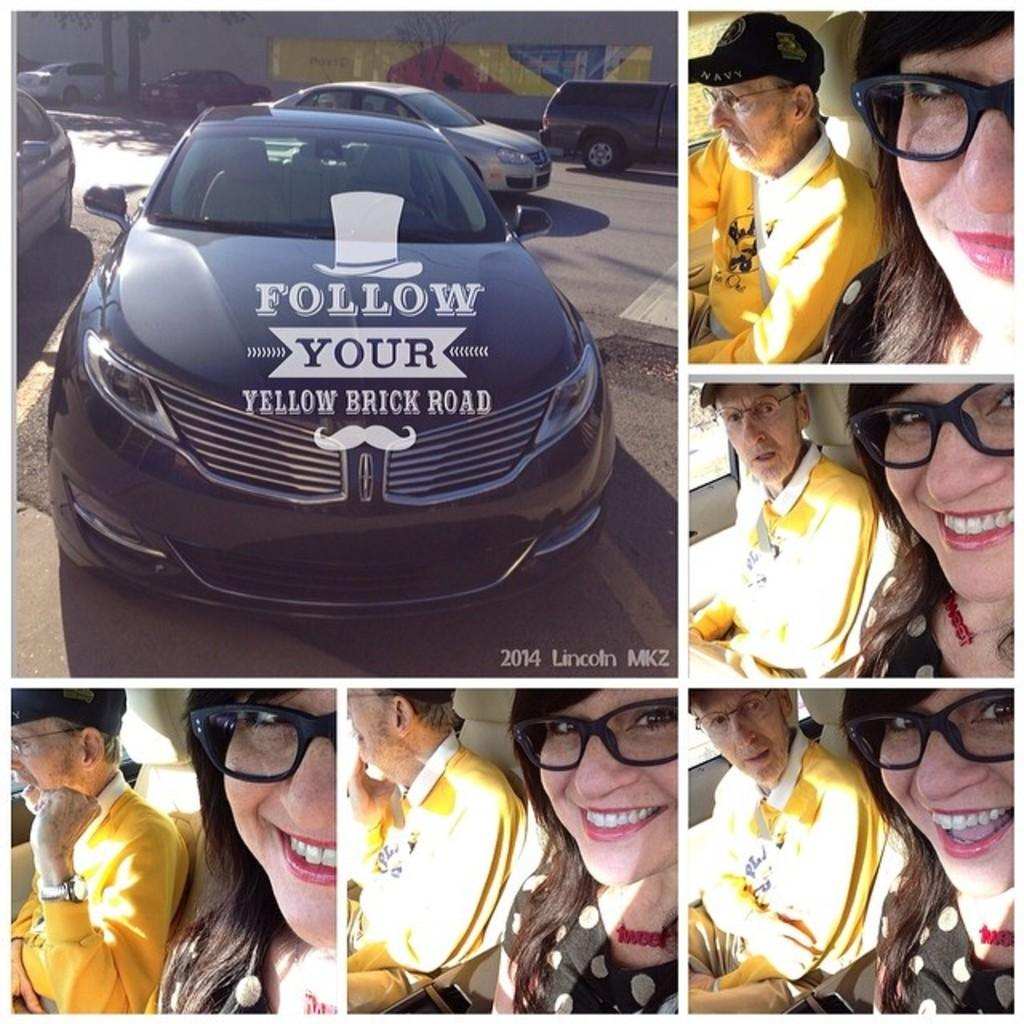What types of objects can be seen in the image? There are vehicles in the image. Can you describe the people in the image? There is an old man and a woman in the image. What type of bait is being used by the old man in the image? There is no indication of fishing or bait in the image; the old man is simply present with the woman and vehicles. 